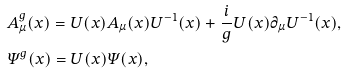<formula> <loc_0><loc_0><loc_500><loc_500>& A ^ { g } _ { \mu } ( x ) = U ( x ) A _ { \mu } ( x ) U ^ { - 1 } ( x ) + \frac { i } { g } U ( x ) \partial _ { \mu } U ^ { - 1 } ( x ) , \\ & { \mathit \Psi } ^ { g } ( x ) = U ( x ) { \mathit \Psi } ( x ) ,</formula> 